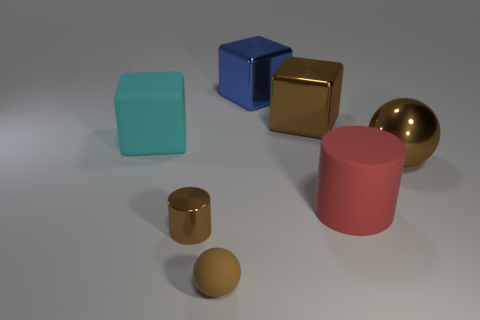What is the color of the metallic object that is the same shape as the brown matte object?
Offer a terse response. Brown. Are there more large metallic things on the right side of the large brown ball than cyan rubber blocks?
Your answer should be compact. No. Does the brown rubber thing have the same shape as the big brown metallic thing that is left of the matte cylinder?
Your answer should be very brief. No. Are there any other things that have the same size as the brown metallic ball?
Offer a terse response. Yes. What size is the brown metallic object that is the same shape as the cyan matte object?
Offer a very short reply. Large. Is the number of large cyan rubber blocks greater than the number of tiny brown blocks?
Ensure brevity in your answer.  Yes. Does the large blue thing have the same shape as the brown matte thing?
Give a very brief answer. No. What is the material of the brown ball in front of the brown ball that is right of the large brown block?
Your answer should be very brief. Rubber. What material is the cube that is the same color as the small cylinder?
Your response must be concise. Metal. Is the metal sphere the same size as the brown cylinder?
Provide a succinct answer. No. 